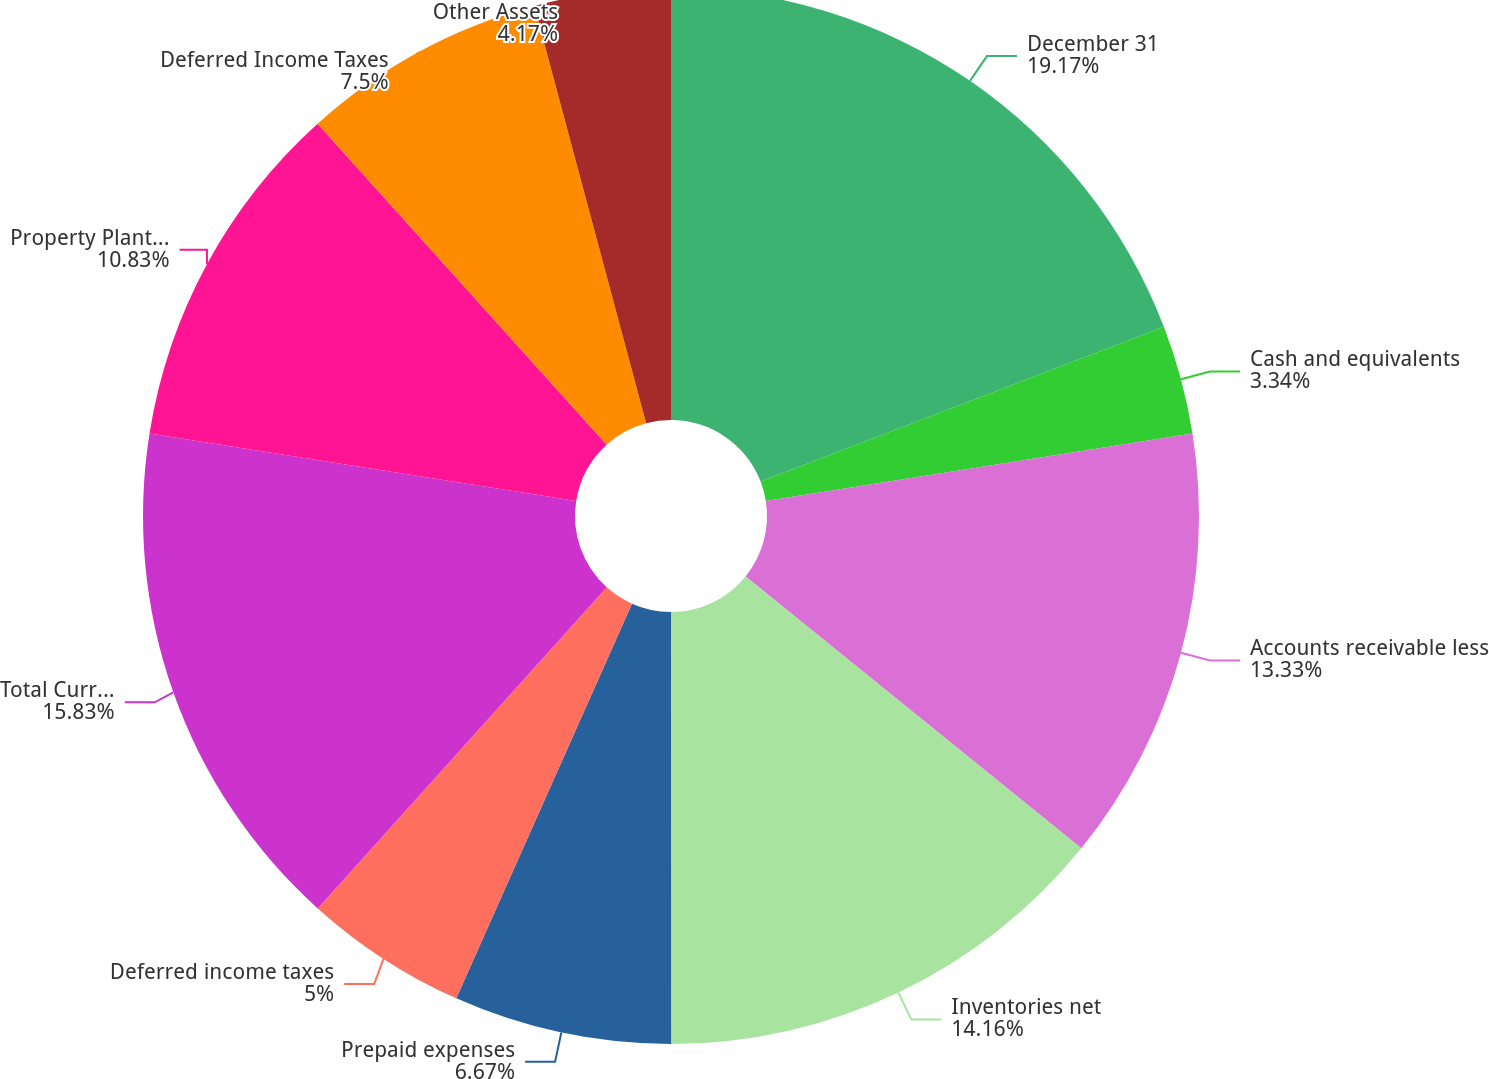<chart> <loc_0><loc_0><loc_500><loc_500><pie_chart><fcel>December 31<fcel>Cash and equivalents<fcel>Accounts receivable less<fcel>Inventories net<fcel>Prepaid expenses<fcel>Deferred income taxes<fcel>Total Current Assets<fcel>Property Plant and Equipment<fcel>Deferred Income Taxes<fcel>Other Assets<nl><fcel>19.16%<fcel>3.34%<fcel>13.33%<fcel>14.16%<fcel>6.67%<fcel>5.0%<fcel>15.83%<fcel>10.83%<fcel>7.5%<fcel>4.17%<nl></chart> 